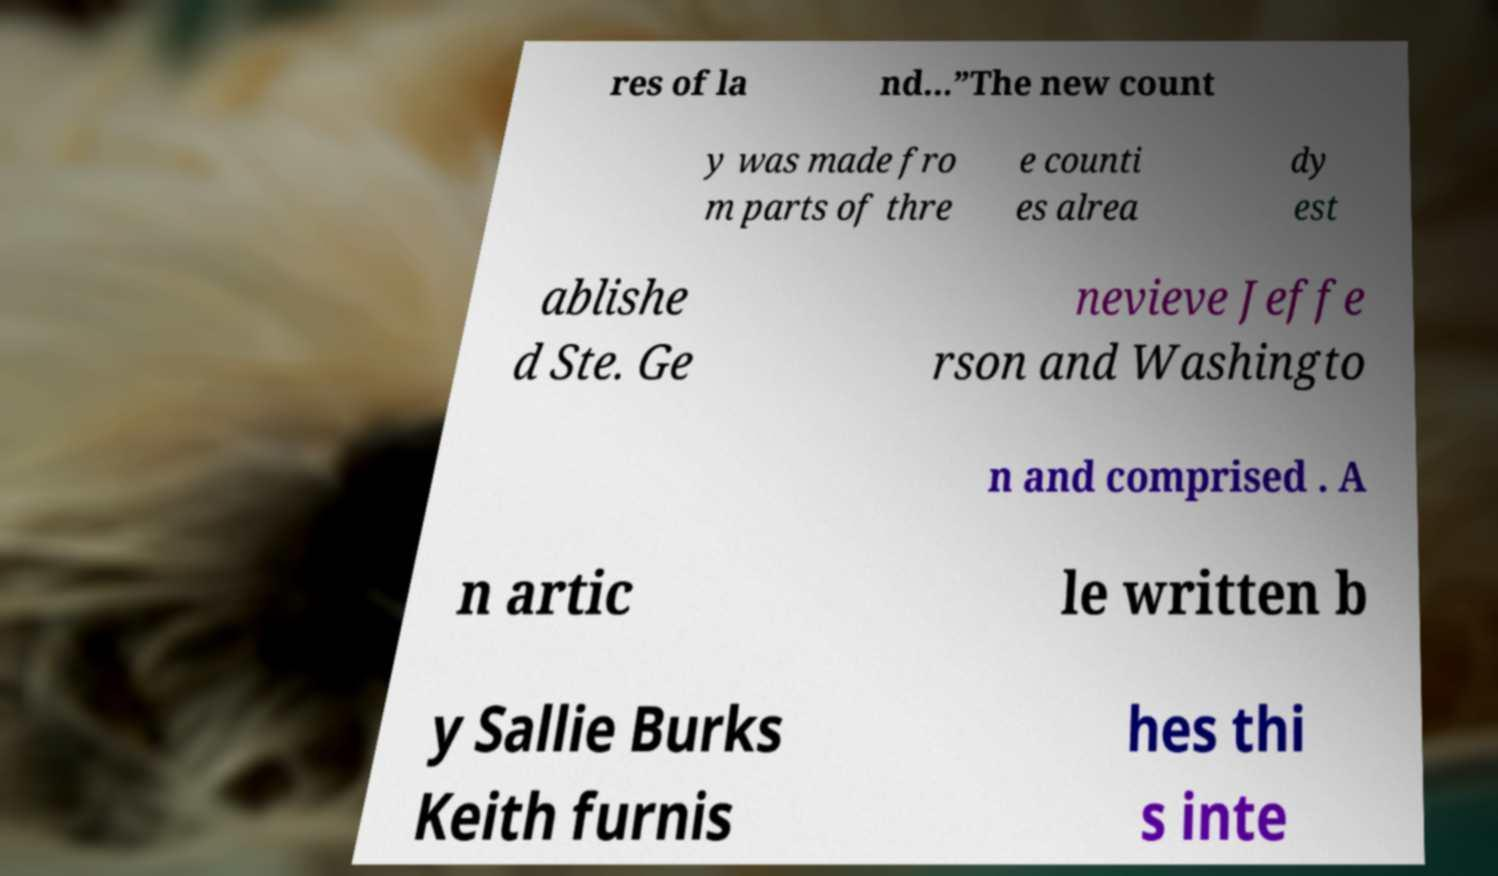Please read and relay the text visible in this image. What does it say? res of la nd...”The new count y was made fro m parts of thre e counti es alrea dy est ablishe d Ste. Ge nevieve Jeffe rson and Washingto n and comprised . A n artic le written b y Sallie Burks Keith furnis hes thi s inte 